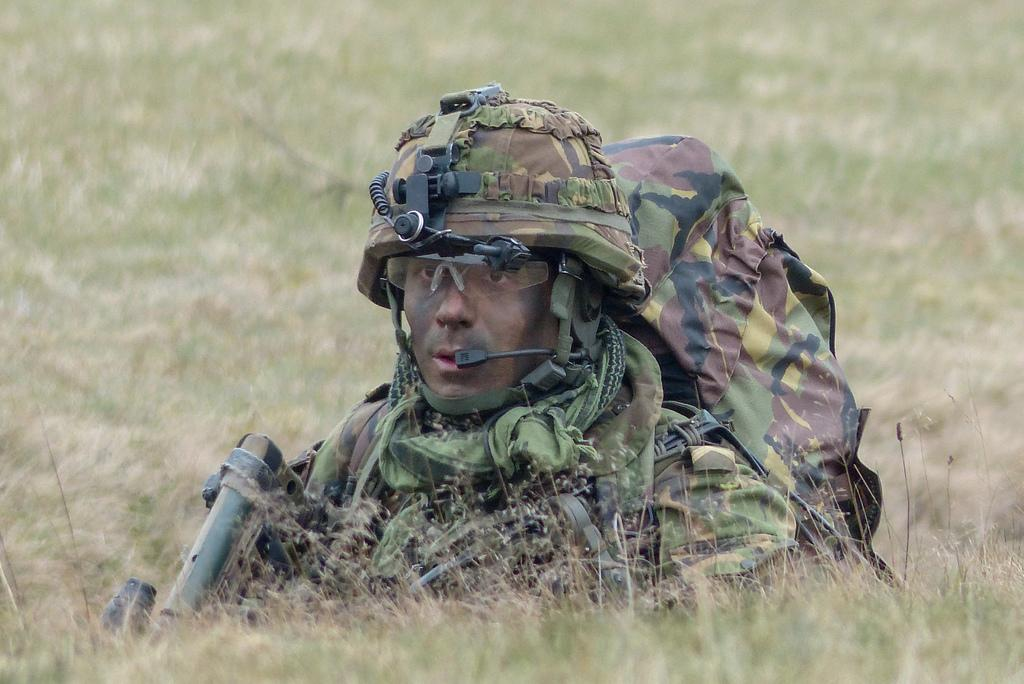What is the main subject of the image? There is a person in the image. What type of clothing is the person wearing? The person is wearing a uniform. What type of protective gear is the person wearing? The person is wearing a helmet. What type of surface is the person standing on? The person is on the grass. What type of mint plant can be seen growing in the image? There is no mint plant present in the image. How many crows can be seen in the image? There are no crows present in the image. 